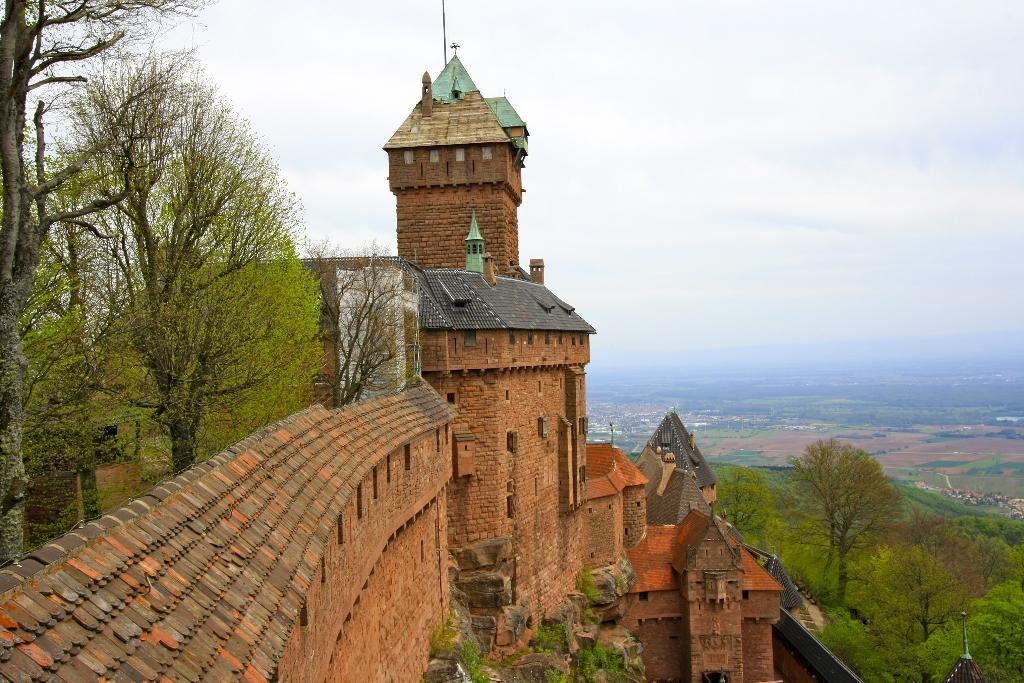What type of structure is visible in the image? There is a building in the image. What can be seen behind the building? There are trees behind the building. What is located in front of the building? There are trees in front of the building. What part of the natural environment is visible in the image? The sky is visible in the background of the image. What type of board is being used by the crook in the image? There is no board or crook present in the image. What is inside the box that is visible in the image? There is no box present in the image. 